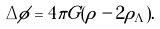Convert formula to latex. <formula><loc_0><loc_0><loc_500><loc_500>\Delta \phi = 4 \pi G ( \rho - 2 \rho _ { \Lambda } ) .</formula> 